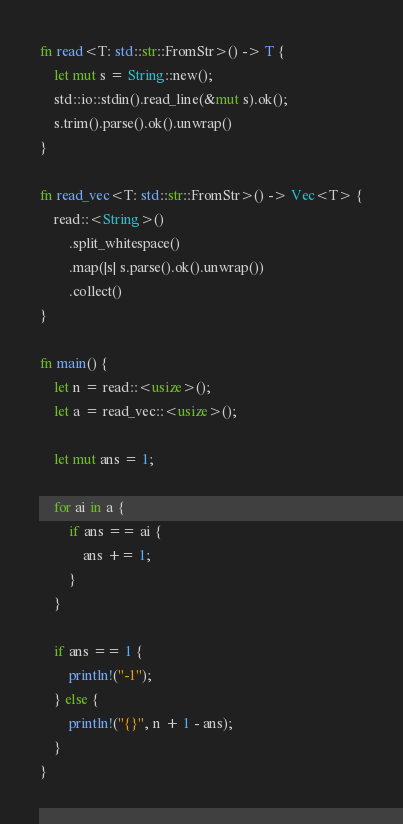Convert code to text. <code><loc_0><loc_0><loc_500><loc_500><_Rust_>fn read<T: std::str::FromStr>() -> T {
    let mut s = String::new();
    std::io::stdin().read_line(&mut s).ok();
    s.trim().parse().ok().unwrap()
}

fn read_vec<T: std::str::FromStr>() -> Vec<T> {
    read::<String>()
        .split_whitespace()
        .map(|s| s.parse().ok().unwrap())
        .collect()
}

fn main() {
    let n = read::<usize>();
    let a = read_vec::<usize>();

    let mut ans = 1;

    for ai in a {
        if ans == ai {
            ans += 1;
        }
    }

    if ans == 1 {
        println!("-1");
    } else {
        println!("{}", n + 1 - ans);
    }
}</code> 